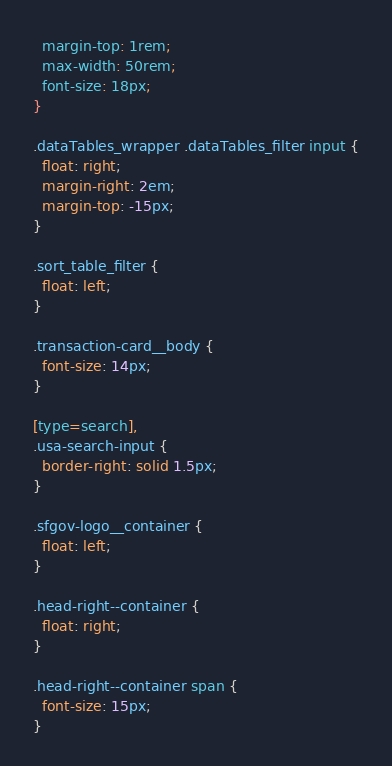Convert code to text. <code><loc_0><loc_0><loc_500><loc_500><_CSS_>  margin-top: 1rem;
  max-width: 50rem;
  font-size: 18px;
}

.dataTables_wrapper .dataTables_filter input {
  float: right;
  margin-right: 2em;
  margin-top: -15px;
}

.sort_table_filter {
  float: left;
}

.transaction-card__body {
  font-size: 14px;
}

[type=search],
.usa-search-input {
  border-right: solid 1.5px;
}

.sfgov-logo__container {
  float: left;
}

.head-right--container {
  float: right;
}

.head-right--container span {
  font-size: 15px;
}

</code> 